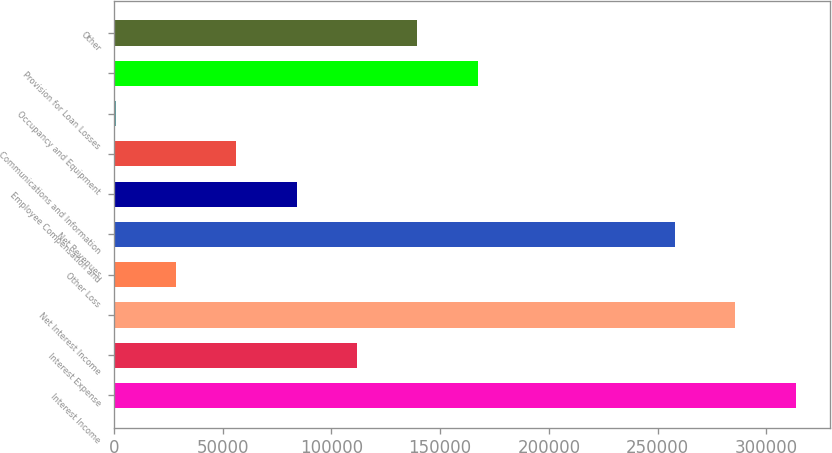Convert chart. <chart><loc_0><loc_0><loc_500><loc_500><bar_chart><fcel>Interest Income<fcel>Interest Expense<fcel>Net Interest Income<fcel>Other Loss<fcel>Net Revenues<fcel>Employee Compensation and<fcel>Communications and Information<fcel>Occupancy and Equipment<fcel>Provision for Loan Losses<fcel>Other<nl><fcel>313500<fcel>111854<fcel>285754<fcel>28618.3<fcel>258009<fcel>84108.9<fcel>56363.6<fcel>873<fcel>167345<fcel>139600<nl></chart> 